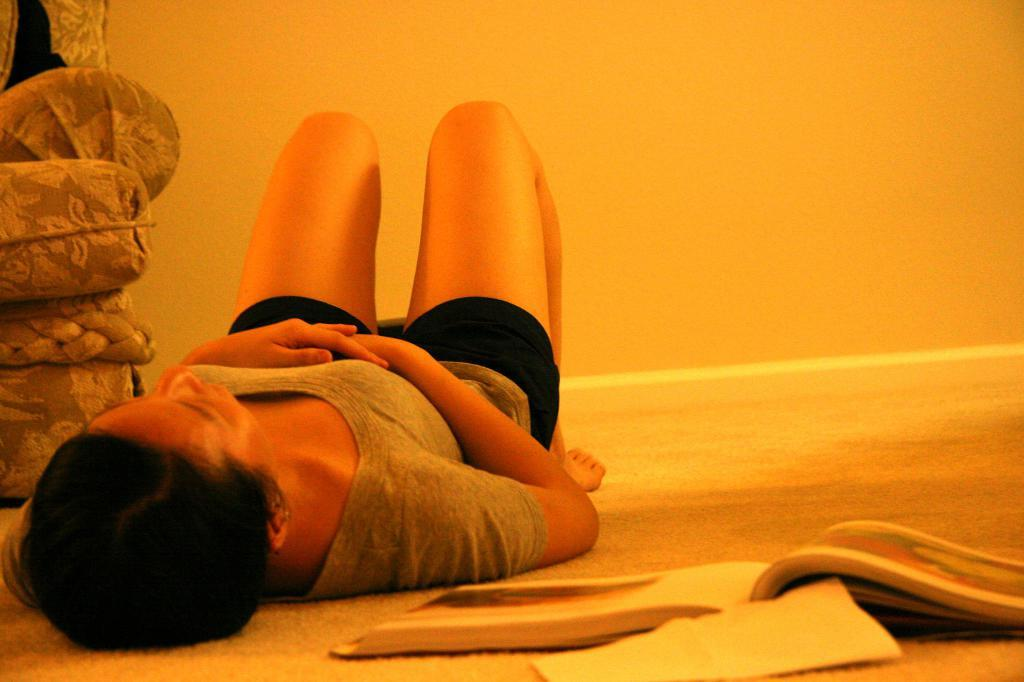What is the woman doing in the image? The woman is laying on the floor in the image. What objects can be seen near the woman? There is a book and a paper in the image. What is visible in the background of the image? There is a wall in the background of the image. What piece of furniture is on the left side of the image? There is a sofa chair on the left side of the image. How many kittens are playing on the plantation in the image? There is no plantation or kittens present in the image. What caused the burst in the image? There is no burst or any indication of an explosion in the image. 